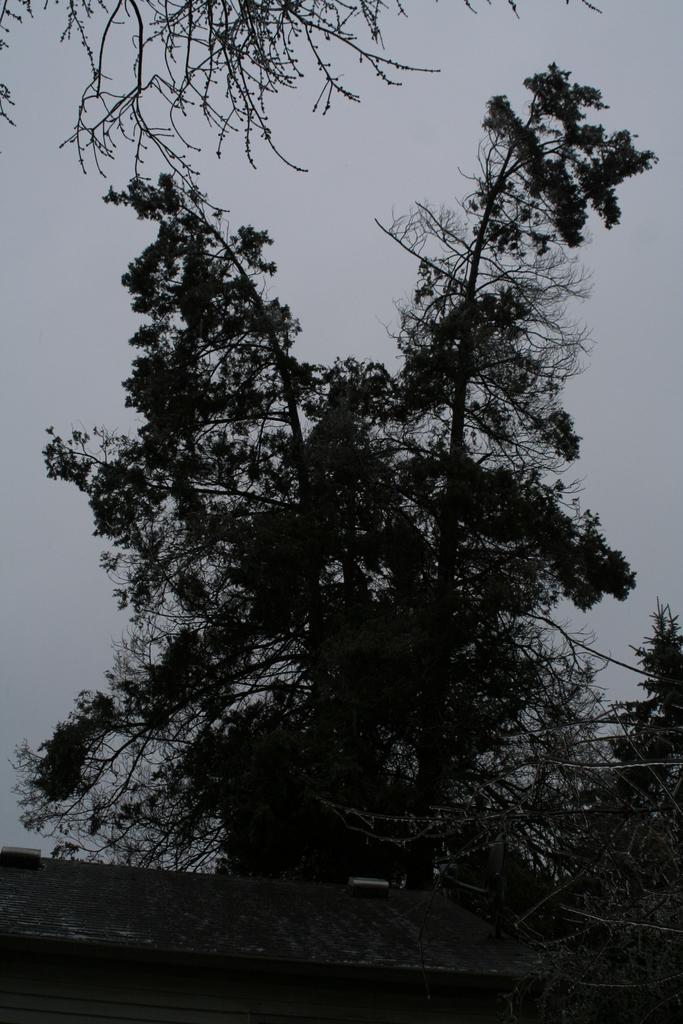How would you summarize this image in a sentence or two? In this picture I can see trees and a wall and I can see a cloudy sky. 